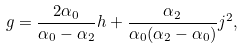<formula> <loc_0><loc_0><loc_500><loc_500>g = \frac { 2 \alpha _ { 0 } } { \alpha _ { 0 } - \alpha _ { 2 } } h + \frac { \alpha _ { 2 } } { \alpha _ { 0 } ( \alpha _ { 2 } - \alpha _ { 0 } ) } j ^ { 2 } ,</formula> 